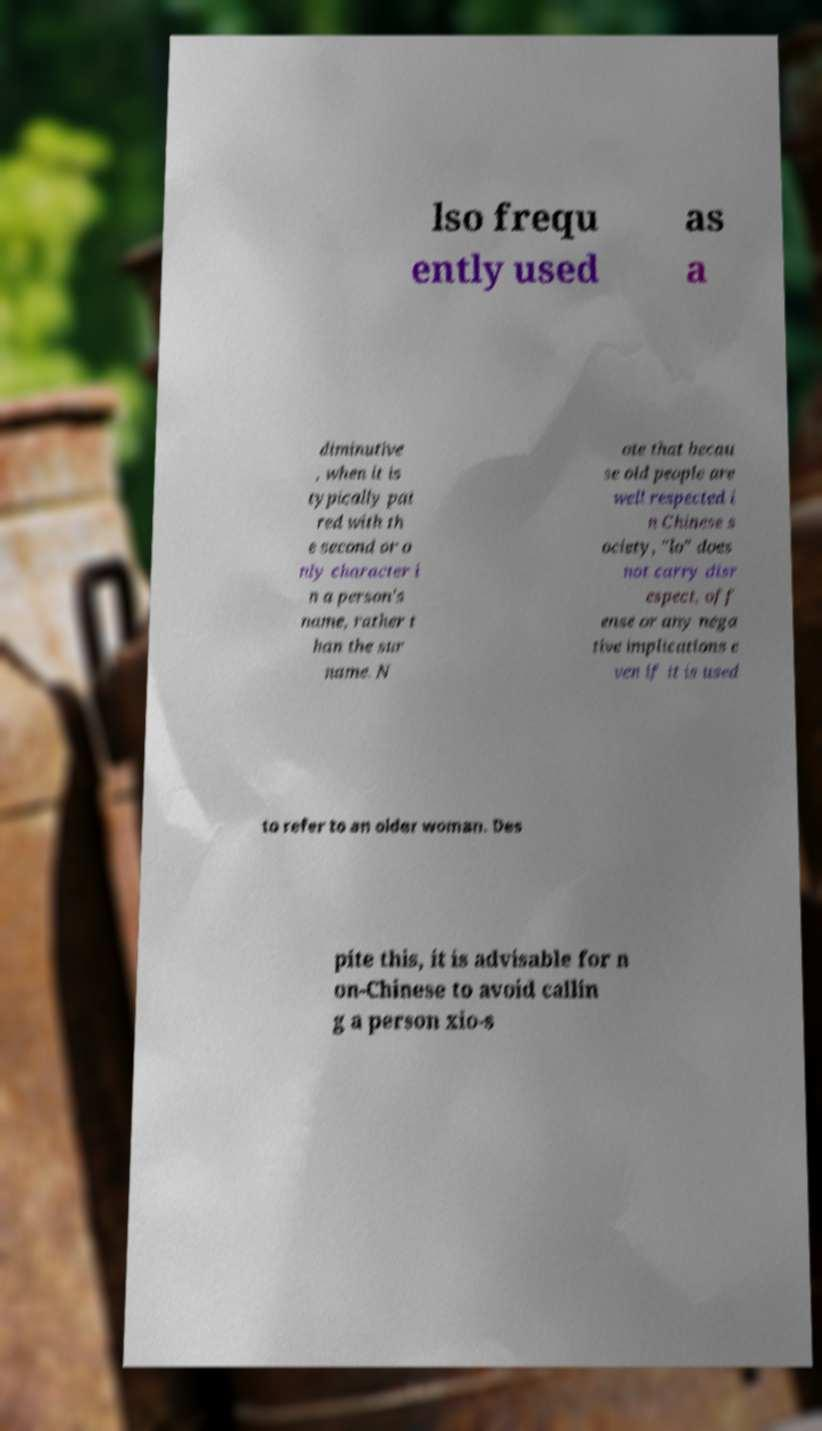What messages or text are displayed in this image? I need them in a readable, typed format. lso frequ ently used as a diminutive , when it is typically pai red with th e second or o nly character i n a person's name, rather t han the sur name. N ote that becau se old people are well respected i n Chinese s ociety, "lo" does not carry disr espect, off ense or any nega tive implications e ven if it is used to refer to an older woman. Des pite this, it is advisable for n on-Chinese to avoid callin g a person xio-s 